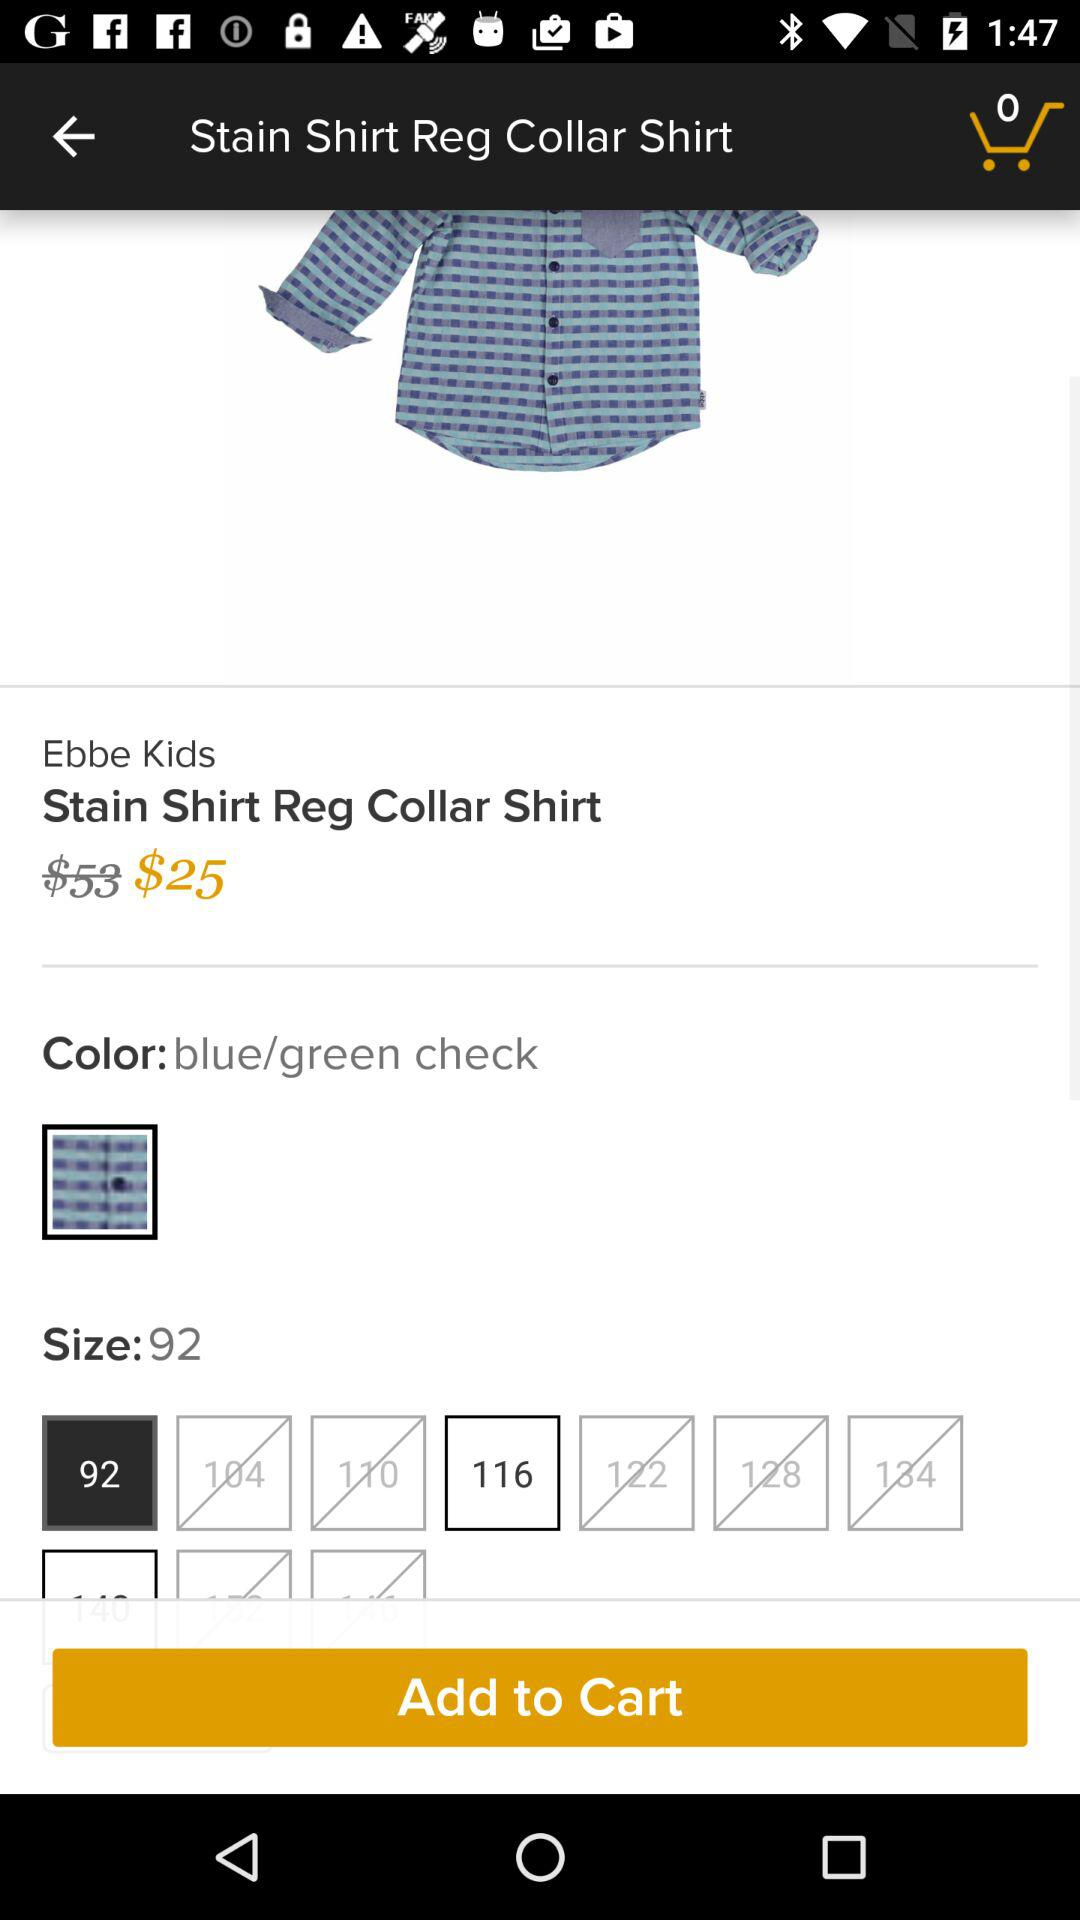How many products are in the cart? There are 0 products in the cart. 